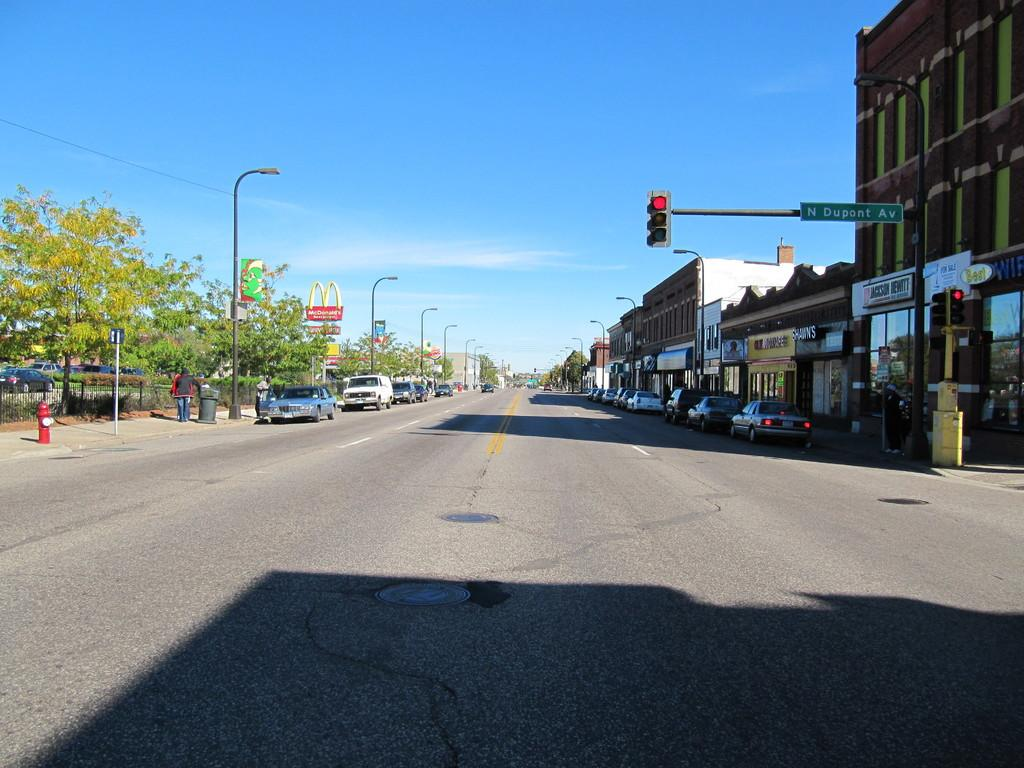<image>
Share a concise interpretation of the image provided. A red traffic light has a street sign for N Dupont AV. 